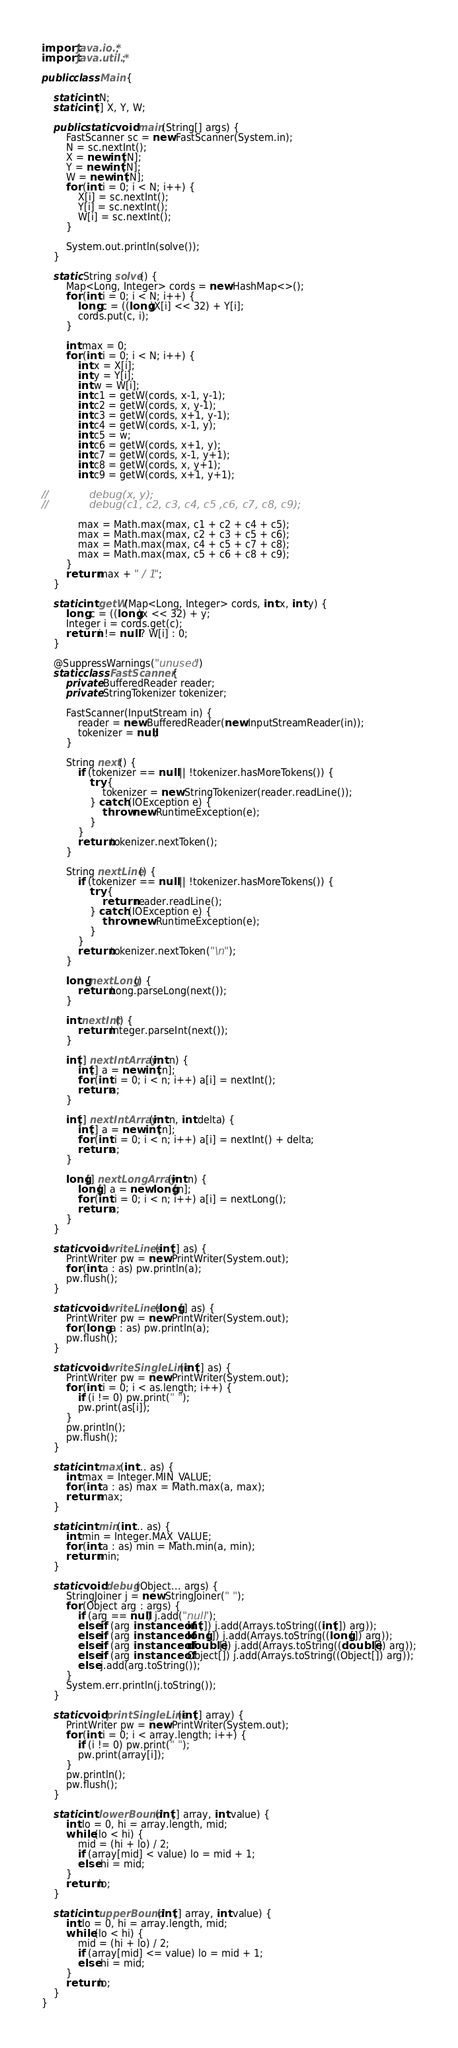Convert code to text. <code><loc_0><loc_0><loc_500><loc_500><_Java_>import java.io.*;
import java.util.*;

public class Main {

    static int N;
    static int[] X, Y, W;

    public static void main(String[] args) {
        FastScanner sc = new FastScanner(System.in);
        N = sc.nextInt();
        X = new int[N];
        Y = new int[N];
        W = new int[N];
        for (int i = 0; i < N; i++) {
            X[i] = sc.nextInt();
            Y[i] = sc.nextInt();
            W[i] = sc.nextInt();
        }

        System.out.println(solve());
    }

    static String solve() {
        Map<Long, Integer> cords = new HashMap<>();
        for (int i = 0; i < N; i++) {
            long c = ((long)X[i] << 32) + Y[i];
            cords.put(c, i);
        }

        int max = 0;
        for (int i = 0; i < N; i++) {
            int x = X[i];
            int y = Y[i];
            int w = W[i];
            int c1 = getW(cords, x-1, y-1);
            int c2 = getW(cords, x, y-1);
            int c3 = getW(cords, x+1, y-1);
            int c4 = getW(cords, x-1, y);
            int c5 = w;
            int c6 = getW(cords, x+1, y);
            int c7 = getW(cords, x-1, y+1);
            int c8 = getW(cords, x, y+1);
            int c9 = getW(cords, x+1, y+1);

//            debug(x, y);
//            debug(c1, c2, c3, c4, c5 ,c6, c7, c8, c9);

            max = Math.max(max, c1 + c2 + c4 + c5);
            max = Math.max(max, c2 + c3 + c5 + c6);
            max = Math.max(max, c4 + c5 + c7 + c8);
            max = Math.max(max, c5 + c6 + c8 + c9);
        }
        return max + " / 1";
    }

    static int getW(Map<Long, Integer> cords, int x, int y) {
        long c = ((long)x << 32) + y;
        Integer i = cords.get(c);
        return i != null ? W[i] : 0;
    }

    @SuppressWarnings("unused")
    static class FastScanner {
        private BufferedReader reader;
        private StringTokenizer tokenizer;

        FastScanner(InputStream in) {
            reader = new BufferedReader(new InputStreamReader(in));
            tokenizer = null;
        }

        String next() {
            if (tokenizer == null || !tokenizer.hasMoreTokens()) {
                try {
                    tokenizer = new StringTokenizer(reader.readLine());
                } catch (IOException e) {
                    throw new RuntimeException(e);
                }
            }
            return tokenizer.nextToken();
        }

        String nextLine() {
            if (tokenizer == null || !tokenizer.hasMoreTokens()) {
                try {
                    return reader.readLine();
                } catch (IOException e) {
                    throw new RuntimeException(e);
                }
            }
            return tokenizer.nextToken("\n");
        }

        long nextLong() {
            return Long.parseLong(next());
        }

        int nextInt() {
            return Integer.parseInt(next());
        }

        int[] nextIntArray(int n) {
            int[] a = new int[n];
            for (int i = 0; i < n; i++) a[i] = nextInt();
            return a;
        }

        int[] nextIntArray(int n, int delta) {
            int[] a = new int[n];
            for (int i = 0; i < n; i++) a[i] = nextInt() + delta;
            return a;
        }

        long[] nextLongArray(int n) {
            long[] a = new long[n];
            for (int i = 0; i < n; i++) a[i] = nextLong();
            return a;
        }
    }

    static void writeLines(int[] as) {
        PrintWriter pw = new PrintWriter(System.out);
        for (int a : as) pw.println(a);
        pw.flush();
    }

    static void writeLines(long[] as) {
        PrintWriter pw = new PrintWriter(System.out);
        for (long a : as) pw.println(a);
        pw.flush();
    }

    static void writeSingleLine(int[] as) {
        PrintWriter pw = new PrintWriter(System.out);
        for (int i = 0; i < as.length; i++) {
            if (i != 0) pw.print(" ");
            pw.print(as[i]);
        }
        pw.println();
        pw.flush();
    }

    static int max(int... as) {
        int max = Integer.MIN_VALUE;
        for (int a : as) max = Math.max(a, max);
        return max;
    }

    static int min(int... as) {
        int min = Integer.MAX_VALUE;
        for (int a : as) min = Math.min(a, min);
        return min;
    }

    static void debug(Object... args) {
        StringJoiner j = new StringJoiner(" ");
        for (Object arg : args) {
            if (arg == null) j.add("null");
            else if (arg instanceof int[]) j.add(Arrays.toString((int[]) arg));
            else if (arg instanceof long[]) j.add(Arrays.toString((long[]) arg));
            else if (arg instanceof double[]) j.add(Arrays.toString((double[]) arg));
            else if (arg instanceof Object[]) j.add(Arrays.toString((Object[]) arg));
            else j.add(arg.toString());
        }
        System.err.println(j.toString());
    }

    static void printSingleLine(int[] array) {
        PrintWriter pw = new PrintWriter(System.out);
        for (int i = 0; i < array.length; i++) {
            if (i != 0) pw.print(" ");
            pw.print(array[i]);
        }
        pw.println();
        pw.flush();
    }

    static int lowerBound(int[] array, int value) {
        int lo = 0, hi = array.length, mid;
        while (lo < hi) {
            mid = (hi + lo) / 2;
            if (array[mid] < value) lo = mid + 1;
            else hi = mid;
        }
        return lo;
    }

    static int upperBound(int[] array, int value) {
        int lo = 0, hi = array.length, mid;
        while (lo < hi) {
            mid = (hi + lo) / 2;
            if (array[mid] <= value) lo = mid + 1;
            else hi = mid;
        }
        return lo;
    }
}

</code> 